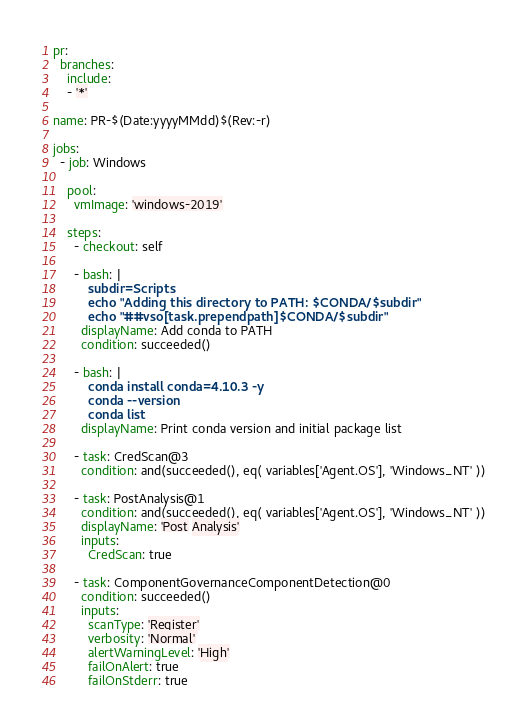Convert code to text. <code><loc_0><loc_0><loc_500><loc_500><_YAML_>pr:
  branches:
    include:
    - '*'

name: PR-$(Date:yyyyMMdd)$(Rev:-r)

jobs:
  - job: Windows

    pool:
      vmImage: 'windows-2019'

    steps:
      - checkout: self

      - bash: |
          subdir=Scripts
          echo "Adding this directory to PATH: $CONDA/$subdir"
          echo "##vso[task.prependpath]$CONDA/$subdir"
        displayName: Add conda to PATH
        condition: succeeded()

      - bash: |
          conda install conda=4.10.3 -y
          conda --version
          conda list
        displayName: Print conda version and initial package list

      - task: CredScan@3
        condition: and(succeeded(), eq( variables['Agent.OS'], 'Windows_NT' ))

      - task: PostAnalysis@1
        condition: and(succeeded(), eq( variables['Agent.OS'], 'Windows_NT' ))
        displayName: 'Post Analysis'
        inputs:
          CredScan: true

      - task: ComponentGovernanceComponentDetection@0
        condition: succeeded()
        inputs:
          scanType: 'Register'
          verbosity: 'Normal'
          alertWarningLevel: 'High'
          failOnAlert: true
          failOnStderr: true
</code> 